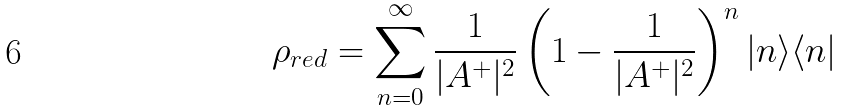Convert formula to latex. <formula><loc_0><loc_0><loc_500><loc_500>\rho _ { r e d } = \sum _ { n = 0 } ^ { \infty } \frac { 1 } { | A ^ { + } | ^ { 2 } } \left ( 1 - \frac { 1 } { | A ^ { + } | ^ { 2 } } \right ) ^ { n } | n \rangle \langle n |</formula> 